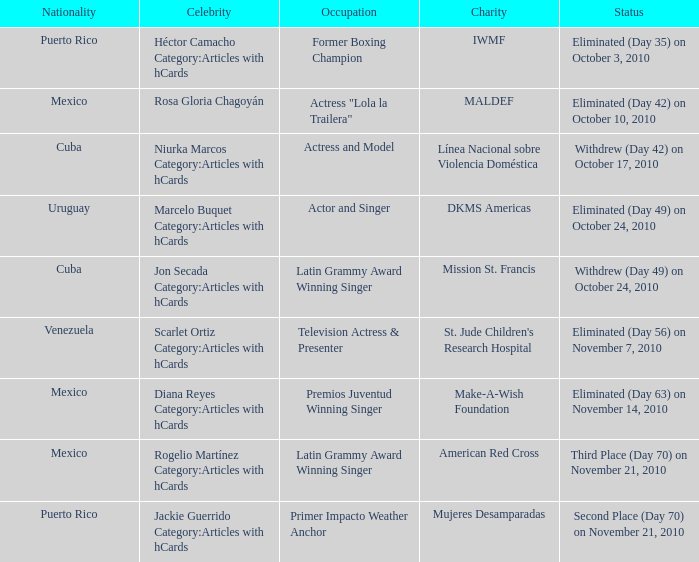Parse the full table. {'header': ['Nationality', 'Celebrity', 'Occupation', 'Charity', 'Status'], 'rows': [['Puerto Rico', 'Héctor Camacho Category:Articles with hCards', 'Former Boxing Champion', 'IWMF', 'Eliminated (Day 35) on October 3, 2010'], ['Mexico', 'Rosa Gloria Chagoyán', 'Actress "Lola la Trailera"', 'MALDEF', 'Eliminated (Day 42) on October 10, 2010'], ['Cuba', 'Niurka Marcos Category:Articles with hCards', 'Actress and Model', 'Línea Nacional sobre Violencia Doméstica', 'Withdrew (Day 42) on October 17, 2010'], ['Uruguay', 'Marcelo Buquet Category:Articles with hCards', 'Actor and Singer', 'DKMS Americas', 'Eliminated (Day 49) on October 24, 2010'], ['Cuba', 'Jon Secada Category:Articles with hCards', 'Latin Grammy Award Winning Singer', 'Mission St. Francis', 'Withdrew (Day 49) on October 24, 2010'], ['Venezuela', 'Scarlet Ortiz Category:Articles with hCards', 'Television Actress & Presenter', "St. Jude Children's Research Hospital", 'Eliminated (Day 56) on November 7, 2010'], ['Mexico', 'Diana Reyes Category:Articles with hCards', 'Premios Juventud Winning Singer', 'Make-A-Wish Foundation', 'Eliminated (Day 63) on November 14, 2010'], ['Mexico', 'Rogelio Martínez Category:Articles with hCards', 'Latin Grammy Award Winning Singer', 'American Red Cross', 'Third Place (Day 70) on November 21, 2010'], ['Puerto Rico', 'Jackie Guerrido Category:Articles with hCards', 'Primer Impacto Weather Anchor', 'Mujeres Desamparadas', 'Second Place (Day 70) on November 21, 2010']]} What is the charity for the celebrity with an occupation title of actor and singer? DKMS Americas. 